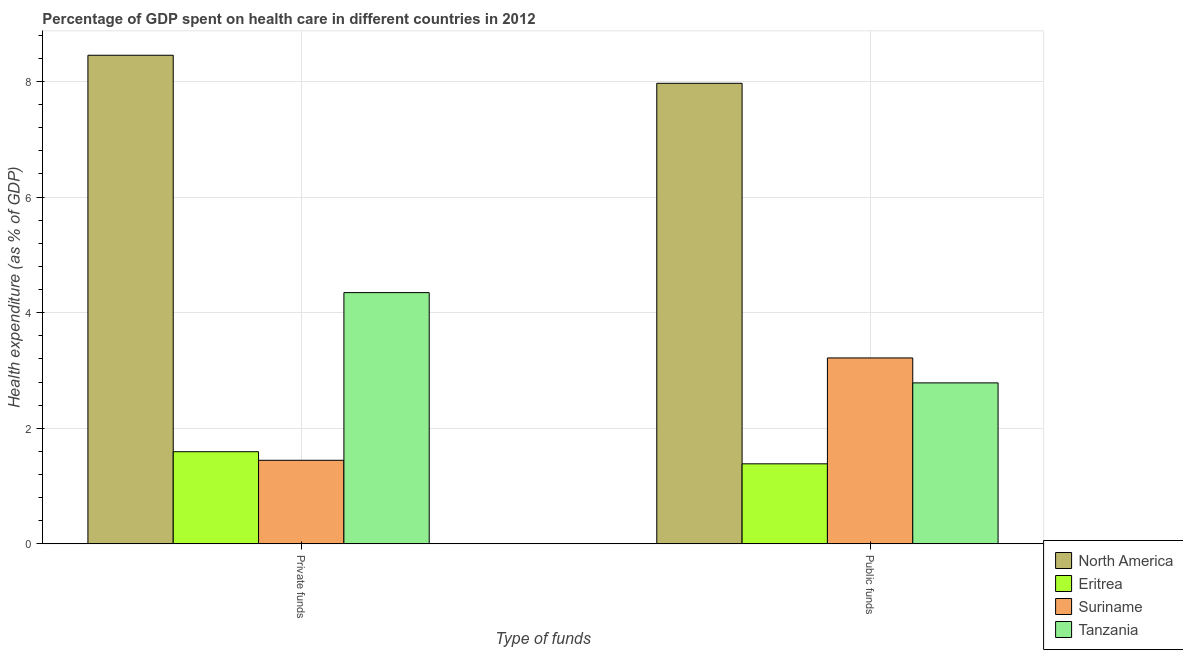How many different coloured bars are there?
Your response must be concise. 4. How many bars are there on the 1st tick from the right?
Provide a short and direct response. 4. What is the label of the 2nd group of bars from the left?
Offer a terse response. Public funds. What is the amount of public funds spent in healthcare in Tanzania?
Give a very brief answer. 2.78. Across all countries, what is the maximum amount of private funds spent in healthcare?
Provide a short and direct response. 8.46. Across all countries, what is the minimum amount of public funds spent in healthcare?
Offer a very short reply. 1.38. In which country was the amount of private funds spent in healthcare minimum?
Ensure brevity in your answer.  Suriname. What is the total amount of private funds spent in healthcare in the graph?
Keep it short and to the point. 15.84. What is the difference between the amount of public funds spent in healthcare in Suriname and that in Eritrea?
Give a very brief answer. 1.83. What is the difference between the amount of private funds spent in healthcare in Tanzania and the amount of public funds spent in healthcare in Suriname?
Your response must be concise. 1.13. What is the average amount of private funds spent in healthcare per country?
Offer a very short reply. 3.96. What is the difference between the amount of public funds spent in healthcare and amount of private funds spent in healthcare in Suriname?
Keep it short and to the point. 1.77. In how many countries, is the amount of private funds spent in healthcare greater than 1.6 %?
Keep it short and to the point. 2. What is the ratio of the amount of public funds spent in healthcare in Tanzania to that in Eritrea?
Give a very brief answer. 2.01. What does the 2nd bar from the left in Private funds represents?
Keep it short and to the point. Eritrea. What does the 2nd bar from the right in Public funds represents?
Ensure brevity in your answer.  Suriname. Where does the legend appear in the graph?
Ensure brevity in your answer.  Bottom right. What is the title of the graph?
Provide a short and direct response. Percentage of GDP spent on health care in different countries in 2012. Does "Congo (Republic)" appear as one of the legend labels in the graph?
Ensure brevity in your answer.  No. What is the label or title of the X-axis?
Offer a very short reply. Type of funds. What is the label or title of the Y-axis?
Give a very brief answer. Health expenditure (as % of GDP). What is the Health expenditure (as % of GDP) in North America in Private funds?
Keep it short and to the point. 8.46. What is the Health expenditure (as % of GDP) of Eritrea in Private funds?
Give a very brief answer. 1.59. What is the Health expenditure (as % of GDP) of Suriname in Private funds?
Keep it short and to the point. 1.44. What is the Health expenditure (as % of GDP) of Tanzania in Private funds?
Keep it short and to the point. 4.35. What is the Health expenditure (as % of GDP) in North America in Public funds?
Your response must be concise. 7.97. What is the Health expenditure (as % of GDP) of Eritrea in Public funds?
Your answer should be compact. 1.38. What is the Health expenditure (as % of GDP) of Suriname in Public funds?
Offer a terse response. 3.22. What is the Health expenditure (as % of GDP) in Tanzania in Public funds?
Offer a terse response. 2.78. Across all Type of funds, what is the maximum Health expenditure (as % of GDP) in North America?
Ensure brevity in your answer.  8.46. Across all Type of funds, what is the maximum Health expenditure (as % of GDP) in Eritrea?
Your answer should be very brief. 1.59. Across all Type of funds, what is the maximum Health expenditure (as % of GDP) in Suriname?
Your answer should be compact. 3.22. Across all Type of funds, what is the maximum Health expenditure (as % of GDP) in Tanzania?
Ensure brevity in your answer.  4.35. Across all Type of funds, what is the minimum Health expenditure (as % of GDP) in North America?
Offer a terse response. 7.97. Across all Type of funds, what is the minimum Health expenditure (as % of GDP) in Eritrea?
Ensure brevity in your answer.  1.38. Across all Type of funds, what is the minimum Health expenditure (as % of GDP) of Suriname?
Your response must be concise. 1.44. Across all Type of funds, what is the minimum Health expenditure (as % of GDP) of Tanzania?
Give a very brief answer. 2.78. What is the total Health expenditure (as % of GDP) in North America in the graph?
Your answer should be compact. 16.42. What is the total Health expenditure (as % of GDP) of Eritrea in the graph?
Your response must be concise. 2.98. What is the total Health expenditure (as % of GDP) of Suriname in the graph?
Provide a short and direct response. 4.66. What is the total Health expenditure (as % of GDP) in Tanzania in the graph?
Offer a very short reply. 7.13. What is the difference between the Health expenditure (as % of GDP) in North America in Private funds and that in Public funds?
Ensure brevity in your answer.  0.49. What is the difference between the Health expenditure (as % of GDP) in Eritrea in Private funds and that in Public funds?
Keep it short and to the point. 0.21. What is the difference between the Health expenditure (as % of GDP) in Suriname in Private funds and that in Public funds?
Provide a short and direct response. -1.77. What is the difference between the Health expenditure (as % of GDP) of Tanzania in Private funds and that in Public funds?
Offer a very short reply. 1.56. What is the difference between the Health expenditure (as % of GDP) in North America in Private funds and the Health expenditure (as % of GDP) in Eritrea in Public funds?
Offer a terse response. 7.07. What is the difference between the Health expenditure (as % of GDP) in North America in Private funds and the Health expenditure (as % of GDP) in Suriname in Public funds?
Your answer should be compact. 5.24. What is the difference between the Health expenditure (as % of GDP) of North America in Private funds and the Health expenditure (as % of GDP) of Tanzania in Public funds?
Provide a short and direct response. 5.67. What is the difference between the Health expenditure (as % of GDP) in Eritrea in Private funds and the Health expenditure (as % of GDP) in Suriname in Public funds?
Give a very brief answer. -1.62. What is the difference between the Health expenditure (as % of GDP) in Eritrea in Private funds and the Health expenditure (as % of GDP) in Tanzania in Public funds?
Your answer should be very brief. -1.19. What is the difference between the Health expenditure (as % of GDP) of Suriname in Private funds and the Health expenditure (as % of GDP) of Tanzania in Public funds?
Offer a very short reply. -1.34. What is the average Health expenditure (as % of GDP) in North America per Type of funds?
Your answer should be very brief. 8.21. What is the average Health expenditure (as % of GDP) in Eritrea per Type of funds?
Make the answer very short. 1.49. What is the average Health expenditure (as % of GDP) of Suriname per Type of funds?
Offer a very short reply. 2.33. What is the average Health expenditure (as % of GDP) of Tanzania per Type of funds?
Ensure brevity in your answer.  3.57. What is the difference between the Health expenditure (as % of GDP) of North America and Health expenditure (as % of GDP) of Eritrea in Private funds?
Your answer should be compact. 6.86. What is the difference between the Health expenditure (as % of GDP) of North America and Health expenditure (as % of GDP) of Suriname in Private funds?
Keep it short and to the point. 7.01. What is the difference between the Health expenditure (as % of GDP) in North America and Health expenditure (as % of GDP) in Tanzania in Private funds?
Your response must be concise. 4.11. What is the difference between the Health expenditure (as % of GDP) in Eritrea and Health expenditure (as % of GDP) in Suriname in Private funds?
Make the answer very short. 0.15. What is the difference between the Health expenditure (as % of GDP) in Eritrea and Health expenditure (as % of GDP) in Tanzania in Private funds?
Your answer should be very brief. -2.75. What is the difference between the Health expenditure (as % of GDP) in Suriname and Health expenditure (as % of GDP) in Tanzania in Private funds?
Give a very brief answer. -2.9. What is the difference between the Health expenditure (as % of GDP) of North America and Health expenditure (as % of GDP) of Eritrea in Public funds?
Make the answer very short. 6.59. What is the difference between the Health expenditure (as % of GDP) in North America and Health expenditure (as % of GDP) in Suriname in Public funds?
Provide a succinct answer. 4.75. What is the difference between the Health expenditure (as % of GDP) in North America and Health expenditure (as % of GDP) in Tanzania in Public funds?
Your answer should be compact. 5.18. What is the difference between the Health expenditure (as % of GDP) in Eritrea and Health expenditure (as % of GDP) in Suriname in Public funds?
Your answer should be compact. -1.83. What is the difference between the Health expenditure (as % of GDP) in Eritrea and Health expenditure (as % of GDP) in Tanzania in Public funds?
Offer a very short reply. -1.4. What is the difference between the Health expenditure (as % of GDP) of Suriname and Health expenditure (as % of GDP) of Tanzania in Public funds?
Give a very brief answer. 0.43. What is the ratio of the Health expenditure (as % of GDP) of North America in Private funds to that in Public funds?
Provide a short and direct response. 1.06. What is the ratio of the Health expenditure (as % of GDP) of Eritrea in Private funds to that in Public funds?
Your response must be concise. 1.15. What is the ratio of the Health expenditure (as % of GDP) of Suriname in Private funds to that in Public funds?
Give a very brief answer. 0.45. What is the ratio of the Health expenditure (as % of GDP) of Tanzania in Private funds to that in Public funds?
Your response must be concise. 1.56. What is the difference between the highest and the second highest Health expenditure (as % of GDP) in North America?
Keep it short and to the point. 0.49. What is the difference between the highest and the second highest Health expenditure (as % of GDP) of Eritrea?
Offer a very short reply. 0.21. What is the difference between the highest and the second highest Health expenditure (as % of GDP) of Suriname?
Keep it short and to the point. 1.77. What is the difference between the highest and the second highest Health expenditure (as % of GDP) in Tanzania?
Provide a short and direct response. 1.56. What is the difference between the highest and the lowest Health expenditure (as % of GDP) in North America?
Provide a succinct answer. 0.49. What is the difference between the highest and the lowest Health expenditure (as % of GDP) of Eritrea?
Provide a short and direct response. 0.21. What is the difference between the highest and the lowest Health expenditure (as % of GDP) of Suriname?
Provide a succinct answer. 1.77. What is the difference between the highest and the lowest Health expenditure (as % of GDP) in Tanzania?
Your response must be concise. 1.56. 